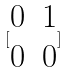<formula> <loc_0><loc_0><loc_500><loc_500>[ \begin{matrix} 0 & 1 \\ 0 & 0 \end{matrix} ]</formula> 